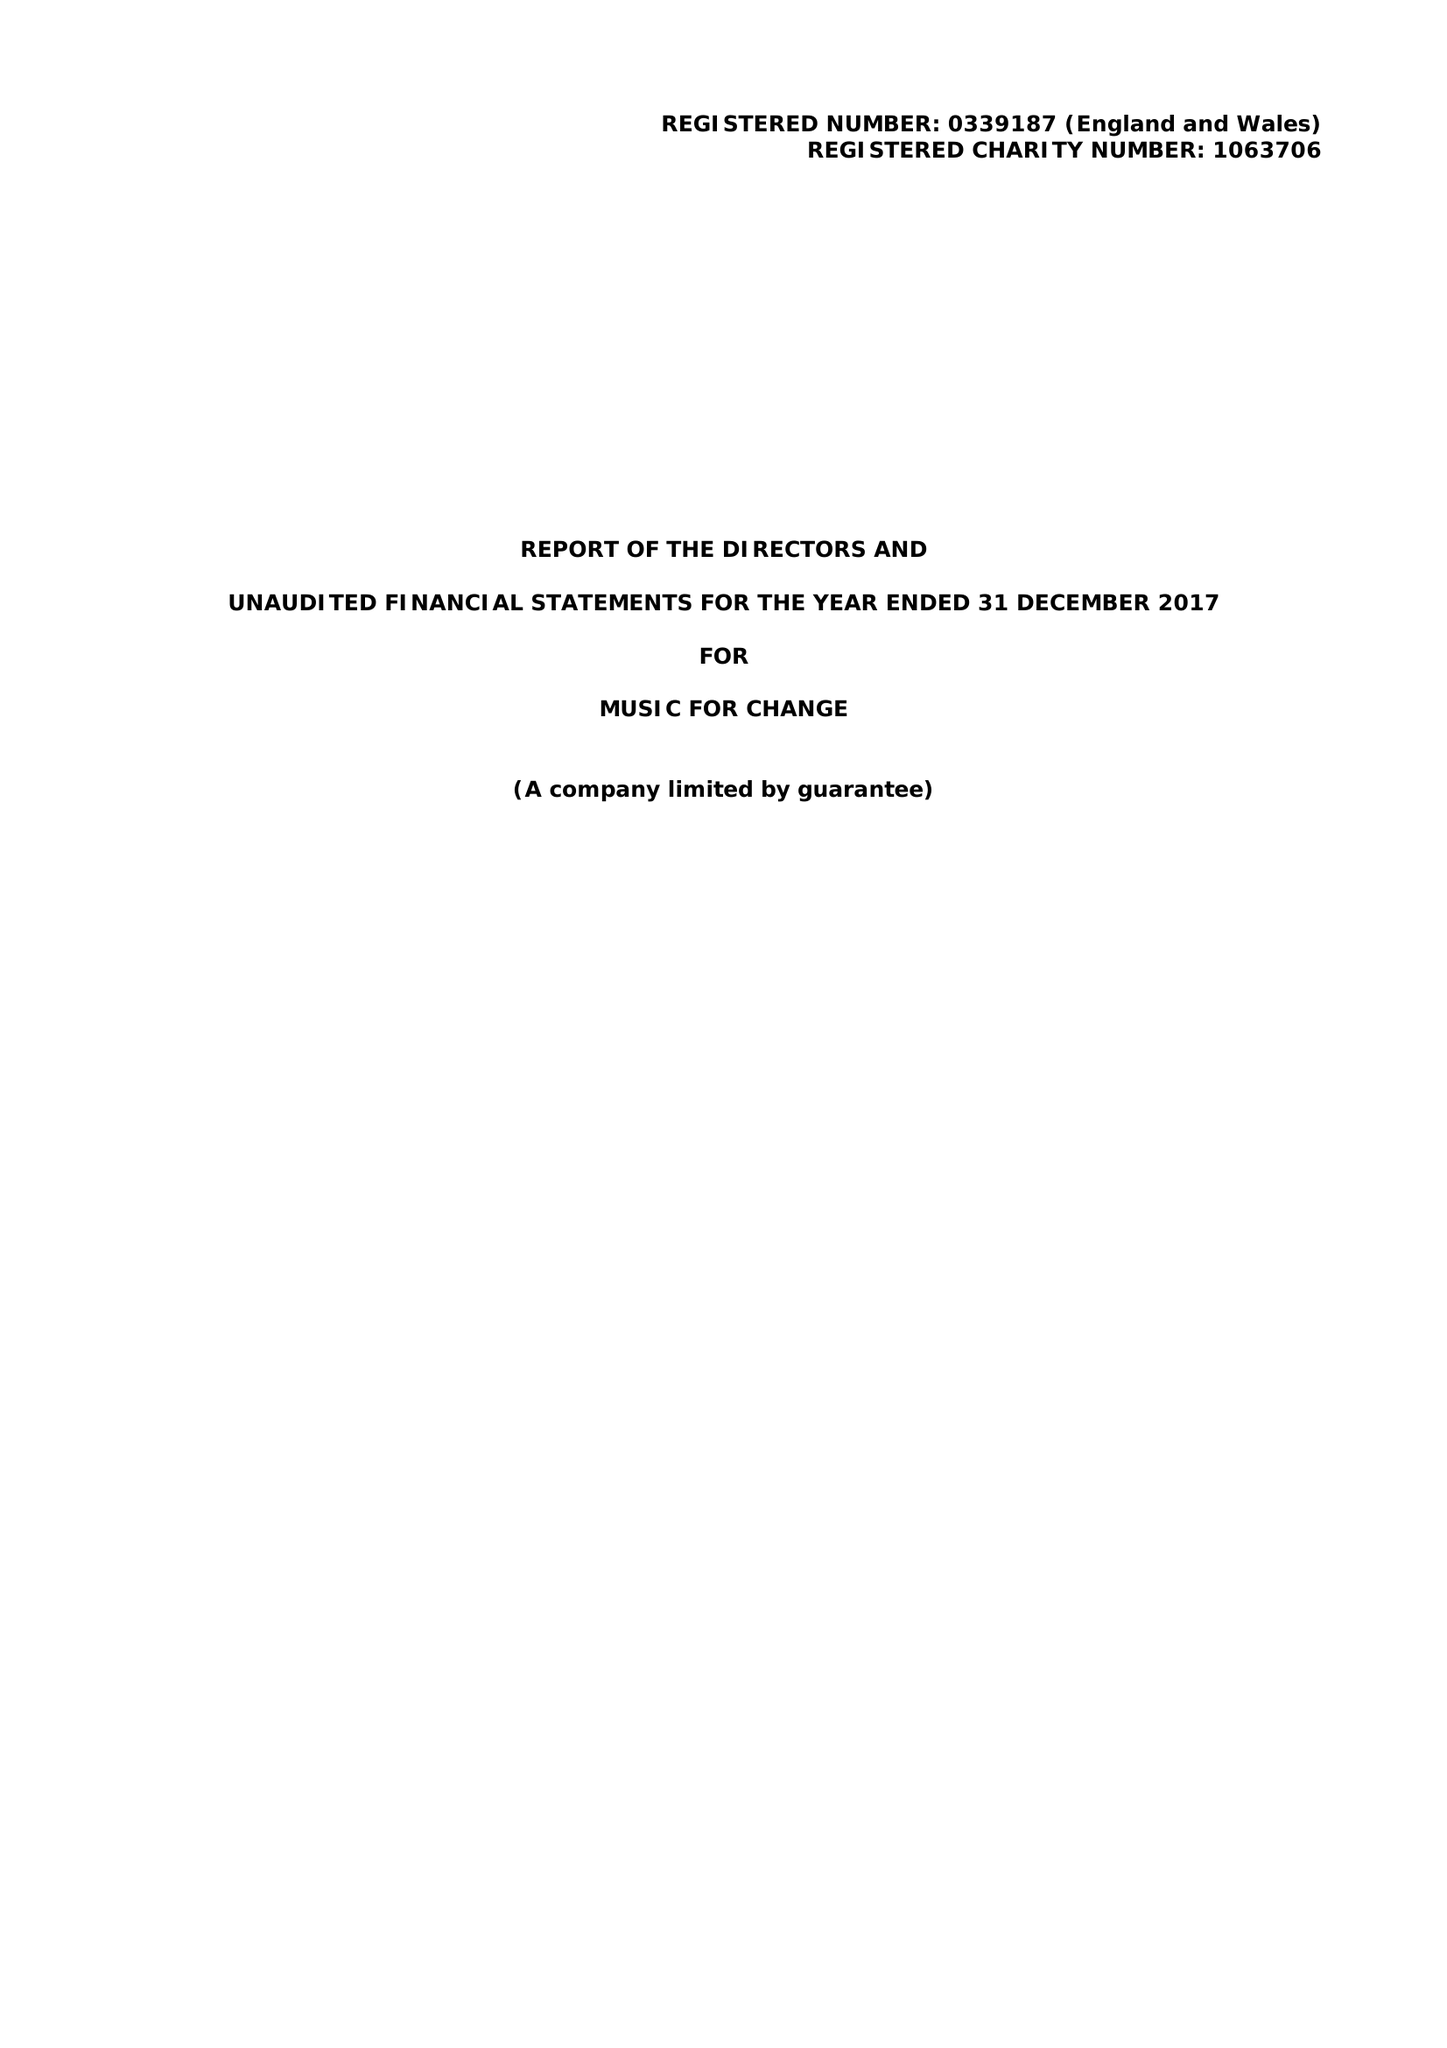What is the value for the address__postcode?
Answer the question using a single word or phrase. CT1 2NR 